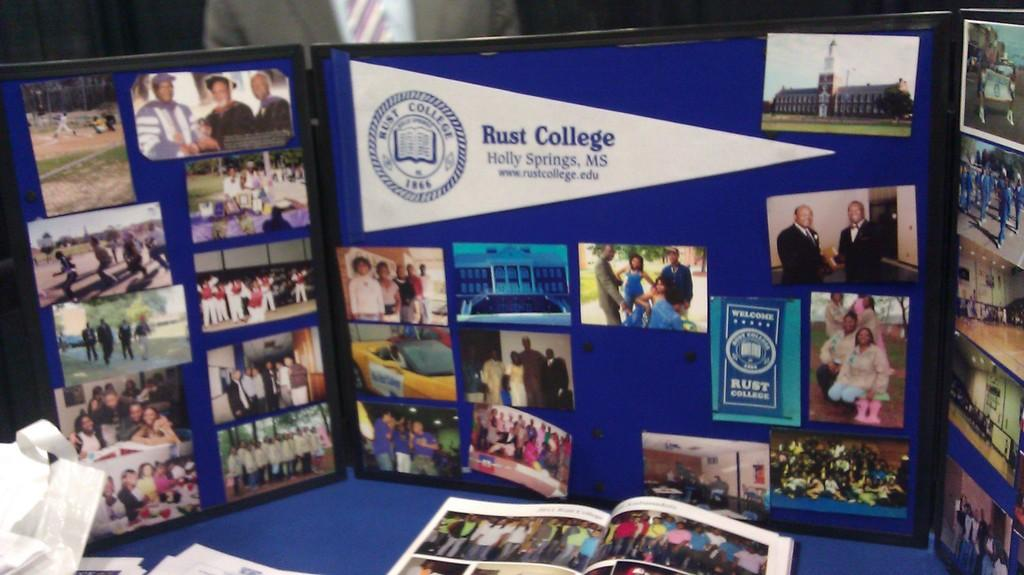<image>
Offer a succinct explanation of the picture presented. collage of Rust College Holly Springs MS man shaking another mans hand. 